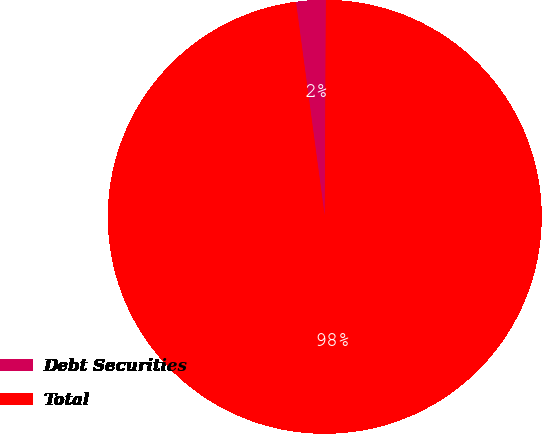Convert chart. <chart><loc_0><loc_0><loc_500><loc_500><pie_chart><fcel>Debt Securities<fcel>Total<nl><fcel>2.21%<fcel>97.79%<nl></chart> 